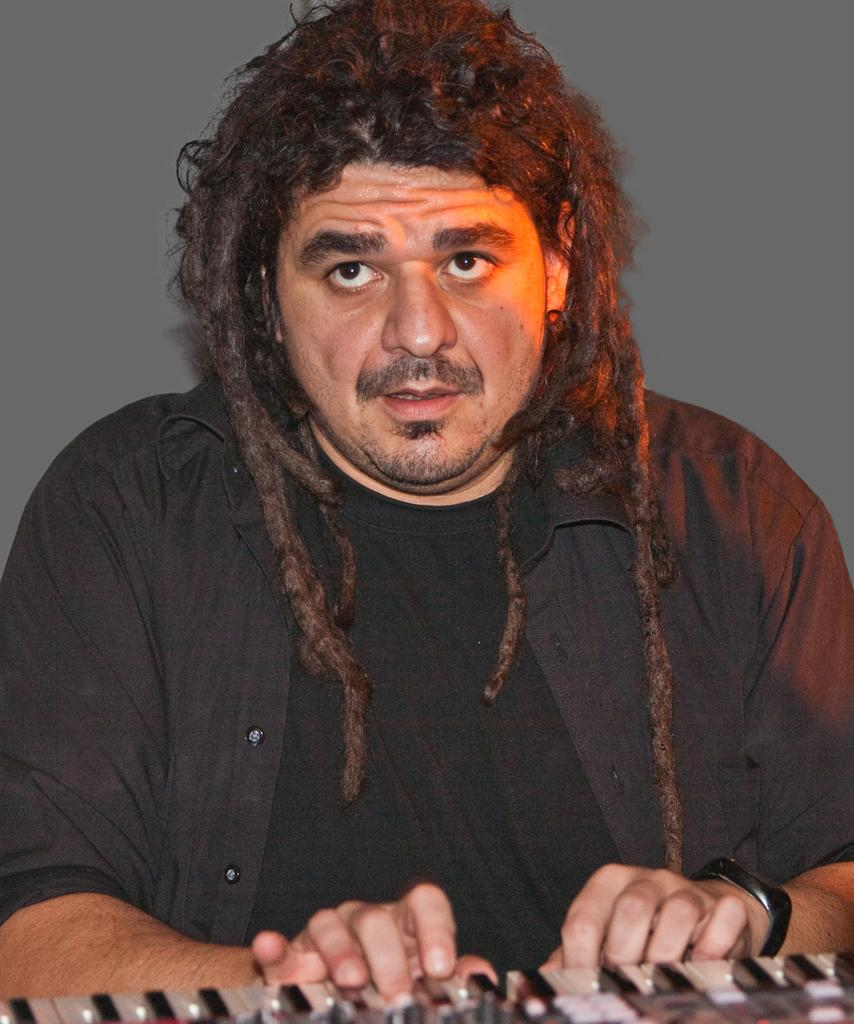How many people are in the image? There is one person in the image. Where is the person located in the image? The person is in the middle of the image. What object is at the bottom of the image? There is a piano at the bottom of the image. What can be seen behind the person in the image? There is a wall in the background of the image. What color is the paint being pulled by the person in the image? There is no paint or pulling action depicted in the image. 